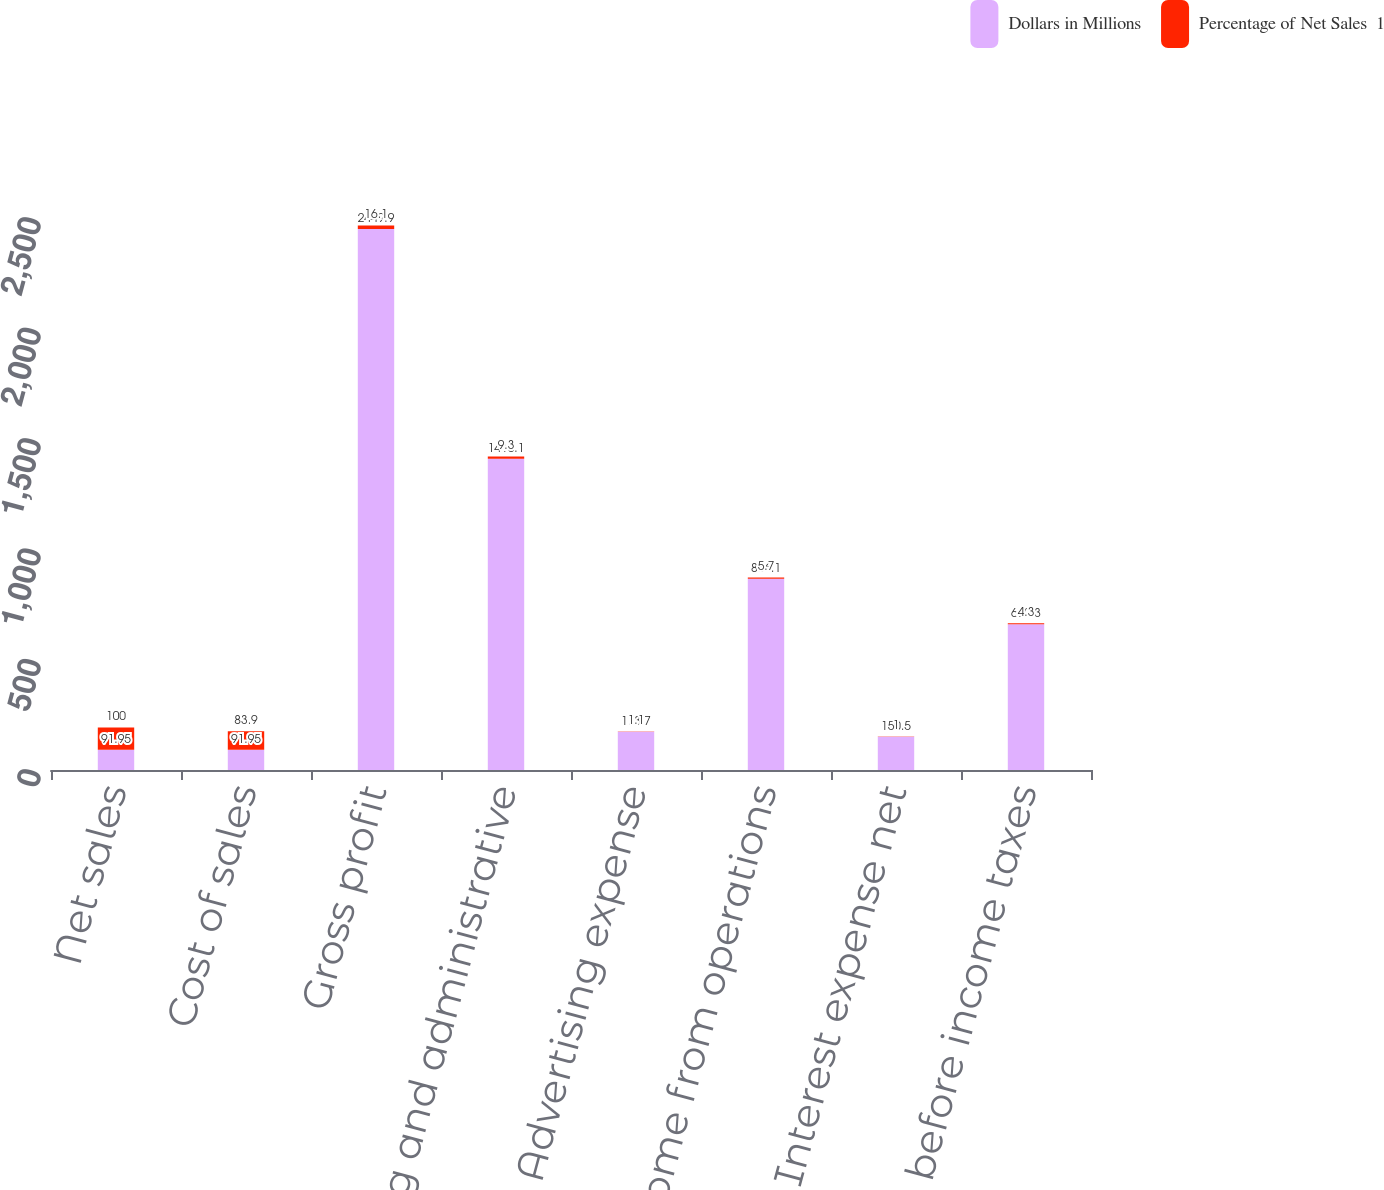Convert chart to OTSL. <chart><loc_0><loc_0><loc_500><loc_500><stacked_bar_chart><ecel><fcel>Net sales<fcel>Cost of sales<fcel>Gross profit<fcel>Selling and administrative<fcel>Advertising expense<fcel>Income from operations<fcel>Interest expense net<fcel>Income before income taxes<nl><fcel>Dollars in Millions<fcel>91.95<fcel>91.95<fcel>2449.9<fcel>1410.1<fcel>173.7<fcel>866.1<fcel>150.5<fcel>660.3<nl><fcel>Percentage of Net Sales  1<fcel>100<fcel>83.9<fcel>16.1<fcel>9.3<fcel>1.1<fcel>5.7<fcel>1<fcel>4.3<nl></chart> 